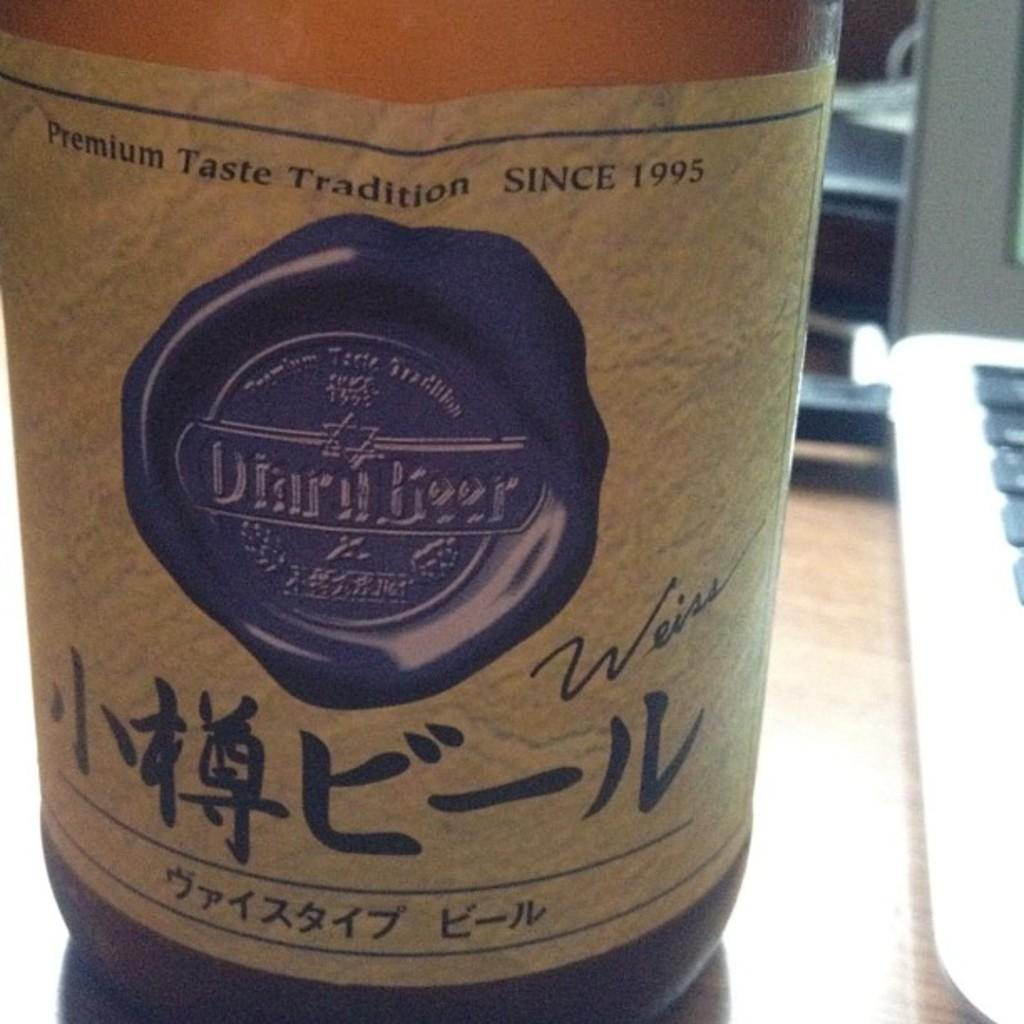<image>
Write a terse but informative summary of the picture. A beer with Asian symbols signed by Weiss claims a premium taste tradition. 